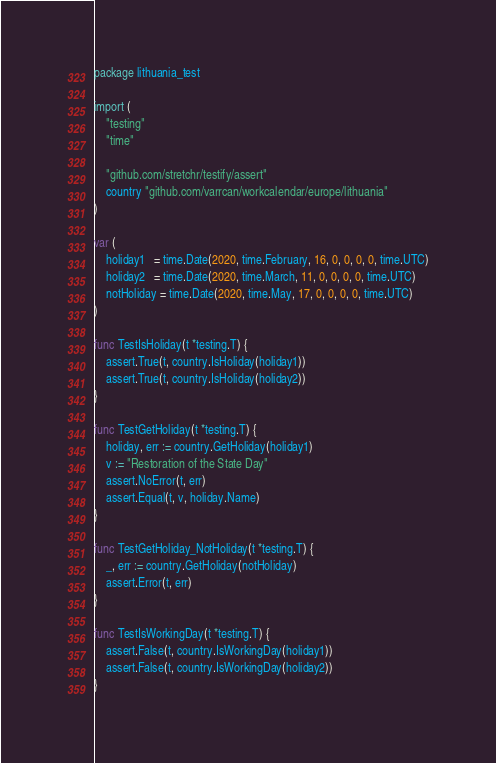<code> <loc_0><loc_0><loc_500><loc_500><_Go_>package lithuania_test

import (
	"testing"
	"time"

	"github.com/stretchr/testify/assert"
	country "github.com/varrcan/workcalendar/europe/lithuania"
)

var (
	holiday1   = time.Date(2020, time.February, 16, 0, 0, 0, 0, time.UTC)
	holiday2   = time.Date(2020, time.March, 11, 0, 0, 0, 0, time.UTC)
	notHoliday = time.Date(2020, time.May, 17, 0, 0, 0, 0, time.UTC)
)

func TestIsHoliday(t *testing.T) {
	assert.True(t, country.IsHoliday(holiday1))
	assert.True(t, country.IsHoliday(holiday2))
}

func TestGetHoliday(t *testing.T) {
	holiday, err := country.GetHoliday(holiday1)
	v := "Restoration of the State Day"
	assert.NoError(t, err)
	assert.Equal(t, v, holiday.Name)
}

func TestGetHoliday_NotHoliday(t *testing.T) {
	_, err := country.GetHoliday(notHoliday)
	assert.Error(t, err)
}

func TestIsWorkingDay(t *testing.T) {
	assert.False(t, country.IsWorkingDay(holiday1))
	assert.False(t, country.IsWorkingDay(holiday2))
}
</code> 